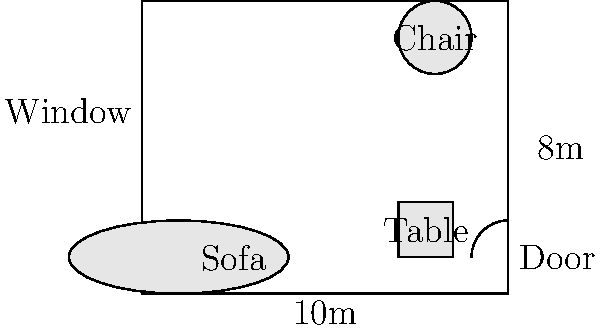In the given floor plan of a minimalist living room, what principle of minimalist design is most evident in the furniture arrangement, and how could you improve the layout to enhance the room's functionality while maintaining its minimalist aesthetic? To answer this question, let's analyze the floor plan and consider the principles of minimalist design:

1. The current layout shows three main pieces of furniture: a sofa, a chair, and a table. This limited number of items aligns with the minimalist principle of "less is more."

2. The furniture is placed along the walls, leaving the center of the room open. This arrangement creates a sense of spaciousness, which is another key aspect of minimalist design.

3. The layout, however, doesn't seem to maximize functionality. The chair is isolated in the corner, and the table is not ideally positioned for use with the sofa.

To improve the layout while maintaining the minimalist aesthetic:

1. Move the sofa to the wall opposite the window. This creates a focal point and allows natural light to illuminate the seating area.

2. Place the chair at an angle next to the sofa, creating a conversation area.

3. Position the table in front of the sofa to serve as a coffee table, enhancing functionality.

4. Consider adding a minimalist floor lamp near the chair for task lighting.

5. Keep the center of the room open to maintain the spacious feel.

This improved layout would maintain the minimalist principle of using few pieces while enhancing functionality by creating a more cohesive seating area and improving traffic flow.
Answer: Open space principle; improve by repositioning furniture for better functionality and flow. 